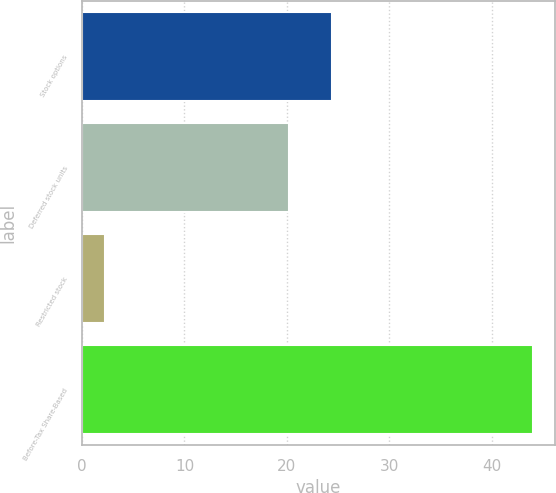<chart> <loc_0><loc_0><loc_500><loc_500><bar_chart><fcel>Stock options<fcel>Deferred stock units<fcel>Restricted stock<fcel>Before-Tax Share-Based<nl><fcel>24.38<fcel>20.2<fcel>2.2<fcel>44<nl></chart> 